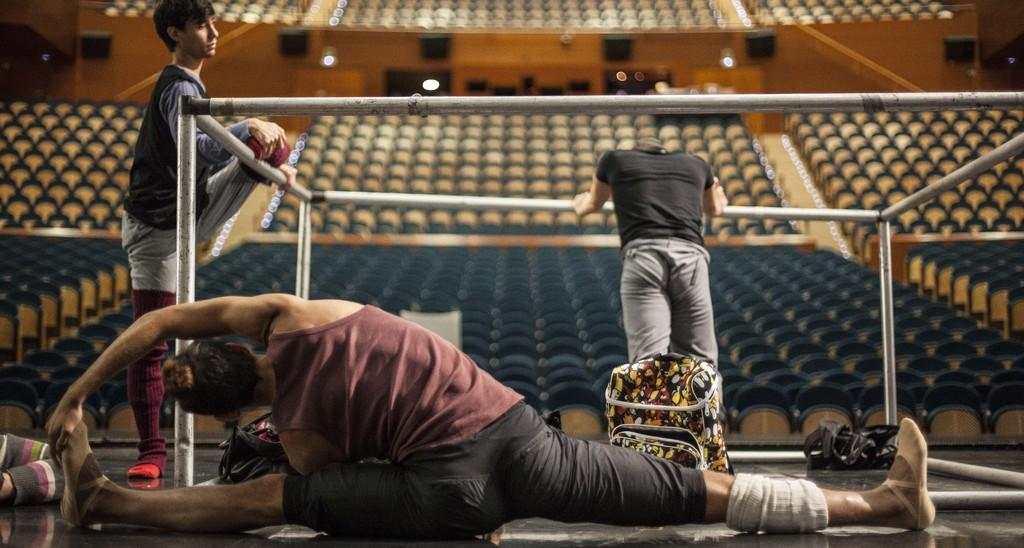What is the person in the image doing? There is a person stretching their body on the floor in the image. What else can be seen on the floor? There are bags on the floor. What architectural features are visible in the image? There are poles visible in the image. What can be seen in the background of the image? There are many chairs and lights in the background. What type of library can be seen in the background of the image? There is no library present in the image; it features a person stretching on the floor, bags, poles, chairs, and lights in the background. 